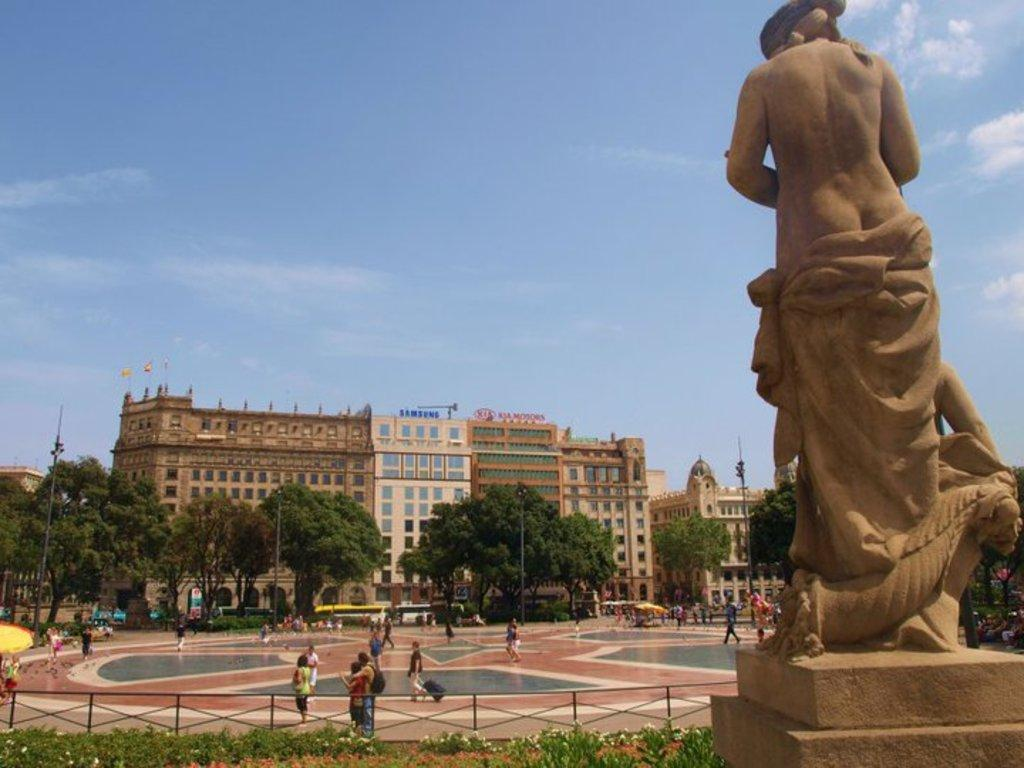What can be seen in the foreground of the picture? In the foreground of the picture, there are plants, flowers, a railing, and a sculpture. What is located in the center of the picture? In the center of the picture, there are trees, people, vehicles, and buildings. How is the weather in the image? The sky is sunny, indicating a clear and pleasant day. Where is the bed located in the image? There is no bed present in the image. What role does the afterthought play in the image? The concept of an afterthought is not applicable to the image, as it is a visual representation and not a thought process. 